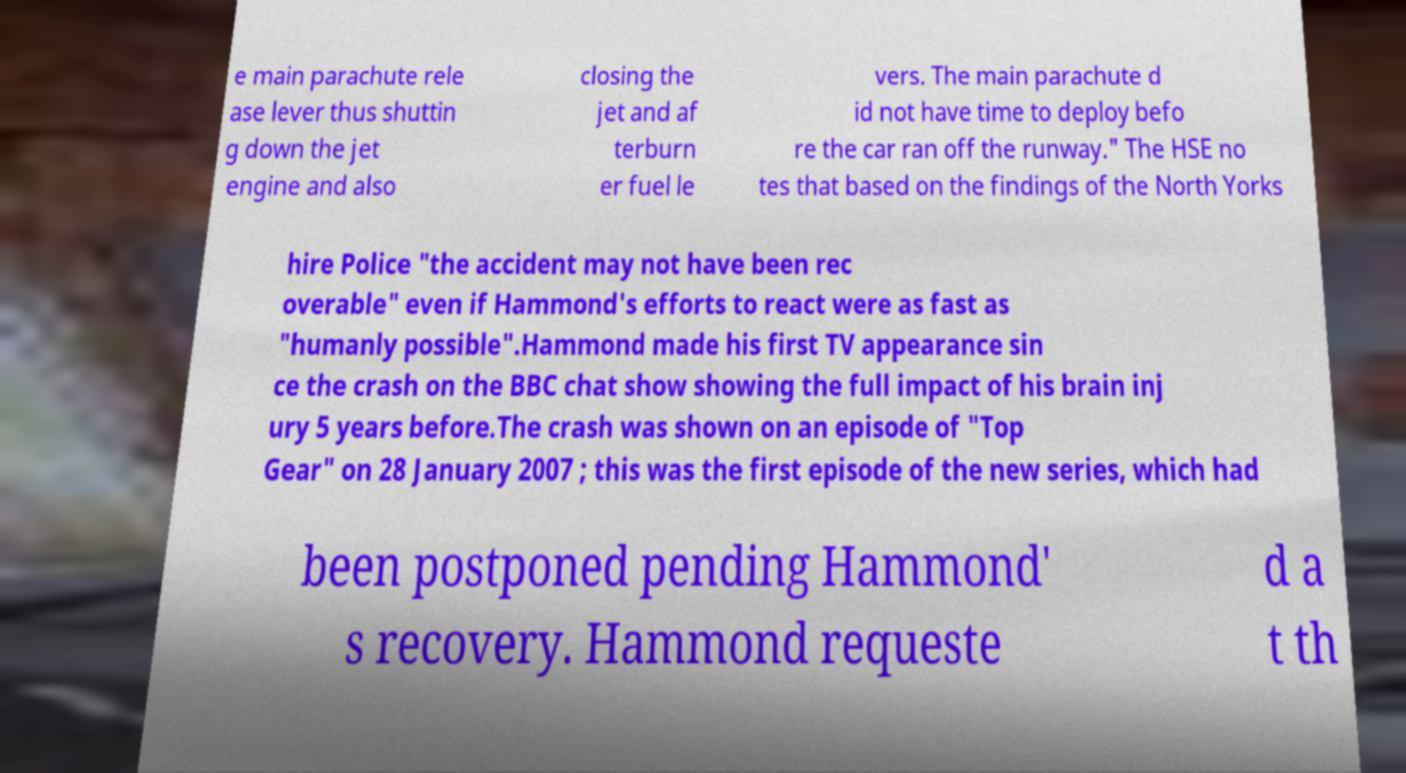For documentation purposes, I need the text within this image transcribed. Could you provide that? e main parachute rele ase lever thus shuttin g down the jet engine and also closing the jet and af terburn er fuel le vers. The main parachute d id not have time to deploy befo re the car ran off the runway." The HSE no tes that based on the findings of the North Yorks hire Police "the accident may not have been rec overable" even if Hammond's efforts to react were as fast as "humanly possible".Hammond made his first TV appearance sin ce the crash on the BBC chat show showing the full impact of his brain inj ury 5 years before.The crash was shown on an episode of "Top Gear" on 28 January 2007 ; this was the first episode of the new series, which had been postponed pending Hammond' s recovery. Hammond requeste d a t th 